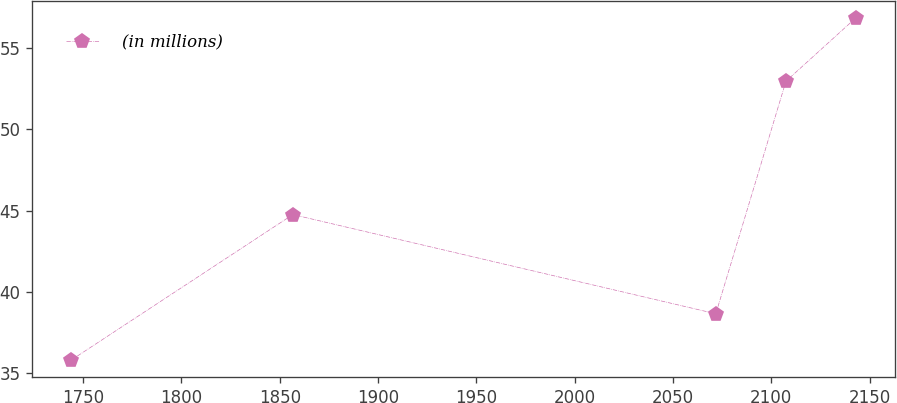Convert chart to OTSL. <chart><loc_0><loc_0><loc_500><loc_500><line_chart><ecel><fcel>(in millions)<nl><fcel>1744.06<fcel>35.82<nl><fcel>1856.68<fcel>44.76<nl><fcel>2071.77<fcel>38.66<nl><fcel>2107.44<fcel>52.96<nl><fcel>2143.11<fcel>56.87<nl></chart> 